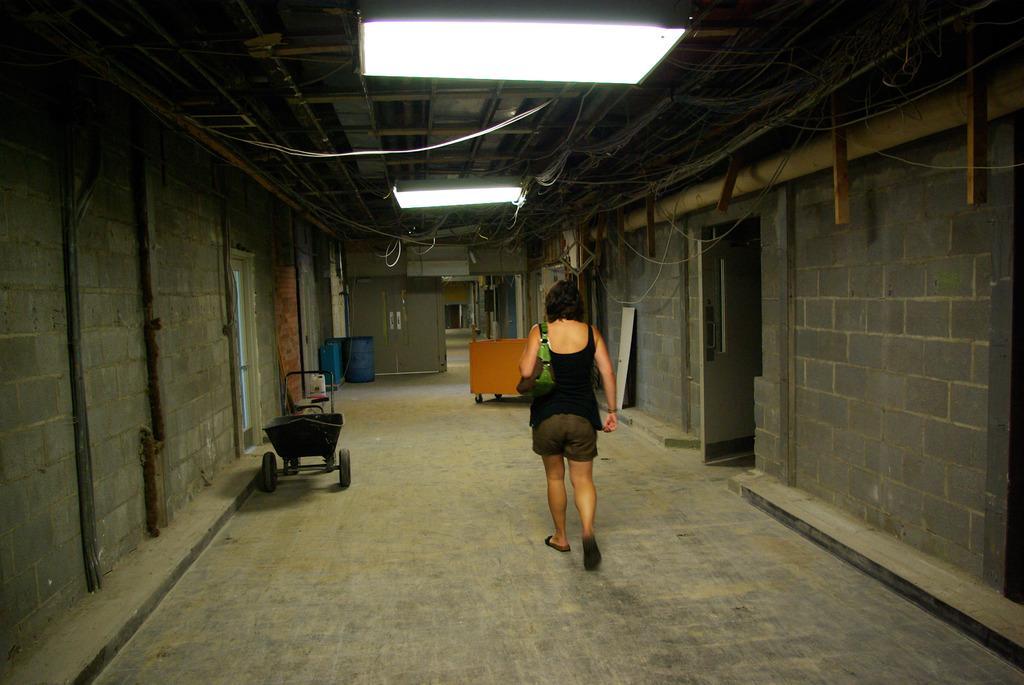Can you describe this image briefly? In this image, there is a woman, she is holding a purse and she is walking, at the left side there is a black color trolley, there are two walls at the right and left side, at the top there are some lights. 